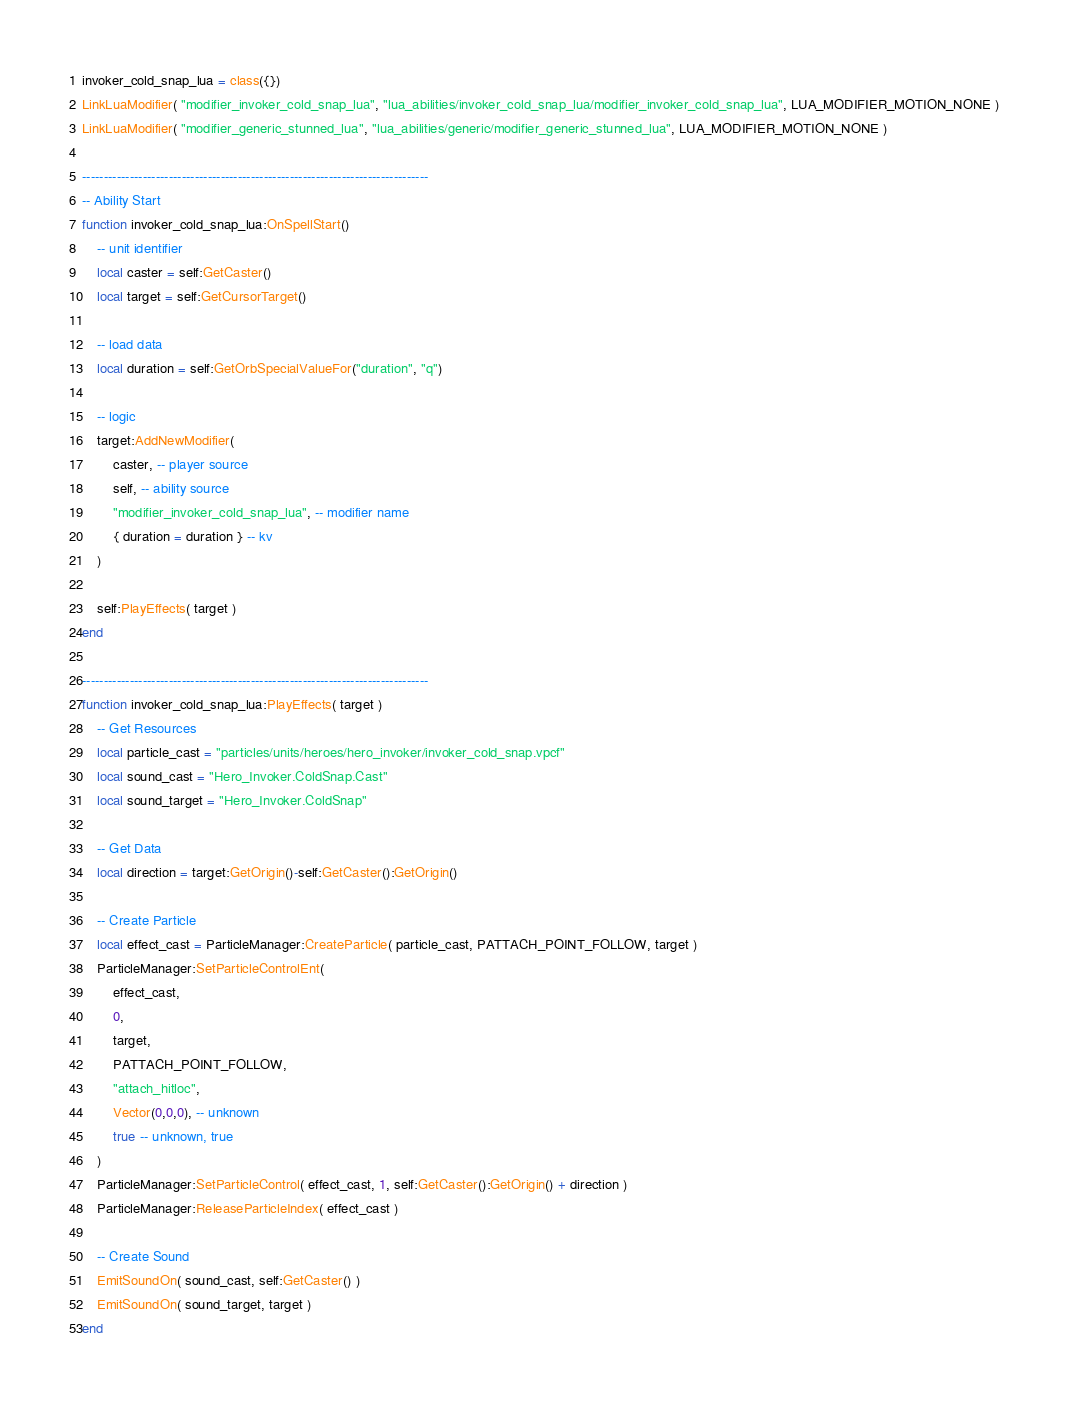<code> <loc_0><loc_0><loc_500><loc_500><_Lua_>invoker_cold_snap_lua = class({})
LinkLuaModifier( "modifier_invoker_cold_snap_lua", "lua_abilities/invoker_cold_snap_lua/modifier_invoker_cold_snap_lua", LUA_MODIFIER_MOTION_NONE )
LinkLuaModifier( "modifier_generic_stunned_lua", "lua_abilities/generic/modifier_generic_stunned_lua", LUA_MODIFIER_MOTION_NONE )

--------------------------------------------------------------------------------
-- Ability Start
function invoker_cold_snap_lua:OnSpellStart()
	-- unit identifier
	local caster = self:GetCaster()
	local target = self:GetCursorTarget()

	-- load data
	local duration = self:GetOrbSpecialValueFor("duration", "q")

	-- logic
	target:AddNewModifier(
		caster, -- player source
		self, -- ability source
		"modifier_invoker_cold_snap_lua", -- modifier name
		{ duration = duration } -- kv
	)

	self:PlayEffects( target )
end

--------------------------------------------------------------------------------
function invoker_cold_snap_lua:PlayEffects( target )
	-- Get Resources
	local particle_cast = "particles/units/heroes/hero_invoker/invoker_cold_snap.vpcf"
	local sound_cast = "Hero_Invoker.ColdSnap.Cast"
	local sound_target = "Hero_Invoker.ColdSnap"

	-- Get Data
	local direction = target:GetOrigin()-self:GetCaster():GetOrigin()

	-- Create Particle
	local effect_cast = ParticleManager:CreateParticle( particle_cast, PATTACH_POINT_FOLLOW, target )
	ParticleManager:SetParticleControlEnt(
		effect_cast,
		0,
		target,
		PATTACH_POINT_FOLLOW,
		"attach_hitloc",
		Vector(0,0,0), -- unknown
		true -- unknown, true
	)
	ParticleManager:SetParticleControl( effect_cast, 1, self:GetCaster():GetOrigin() + direction )
	ParticleManager:ReleaseParticleIndex( effect_cast )

	-- Create Sound
	EmitSoundOn( sound_cast, self:GetCaster() )
	EmitSoundOn( sound_target, target )
end</code> 